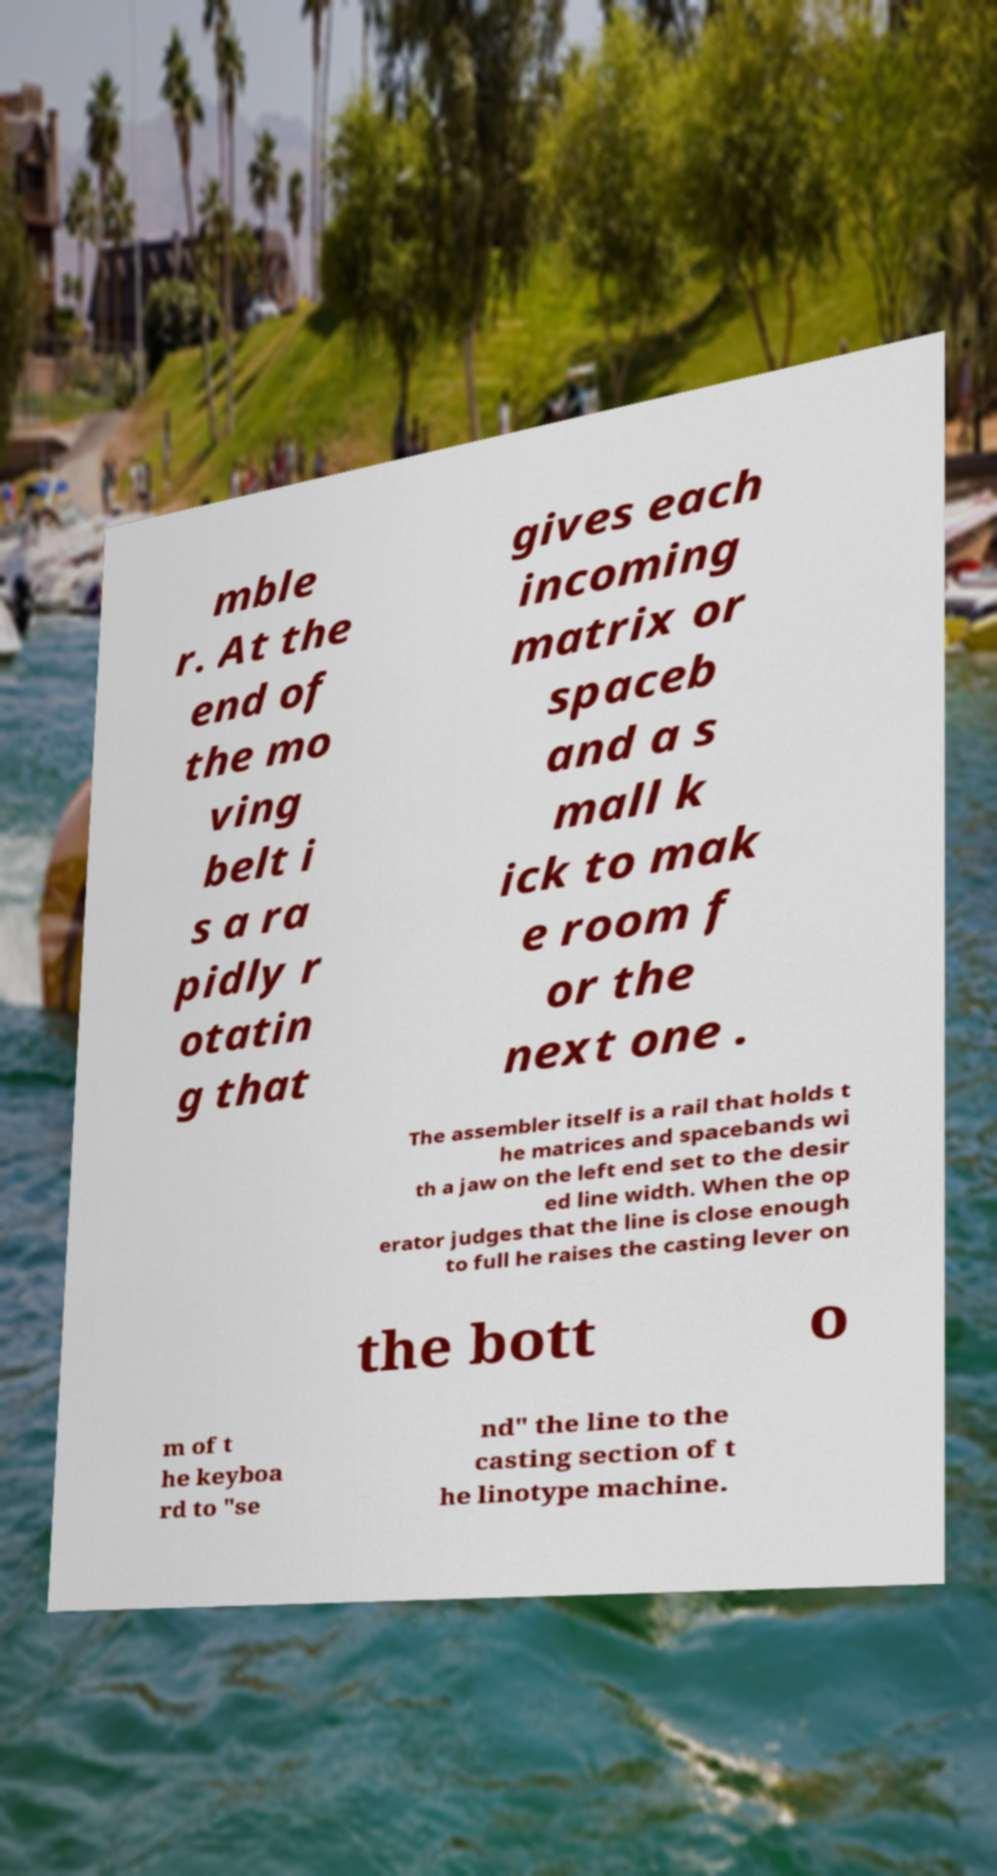I need the written content from this picture converted into text. Can you do that? mble r. At the end of the mo ving belt i s a ra pidly r otatin g that gives each incoming matrix or spaceb and a s mall k ick to mak e room f or the next one . The assembler itself is a rail that holds t he matrices and spacebands wi th a jaw on the left end set to the desir ed line width. When the op erator judges that the line is close enough to full he raises the casting lever on the bott o m of t he keyboa rd to "se nd" the line to the casting section of t he linotype machine. 